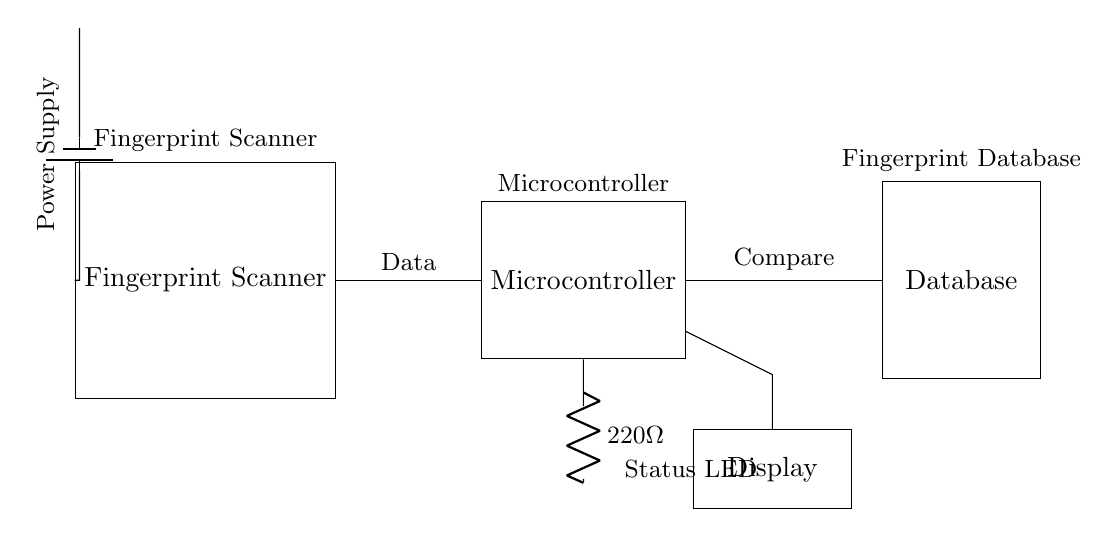What is the main component that collects biometric data? The main component collecting biometric data is the fingerprint scanner, clearly labeled as such in the diagram.
Answer: Fingerprint Scanner What is the purpose of the microcontroller in this circuit? The microcontroller processes the data received from the fingerprint scanner and compares it with the entries in the database.
Answer: Data processing What is connected to the microcontroller for indicating status? A status LED is connected to the microcontroller, which is often used to indicate whether the system is functioning properly or if there is an issue.
Answer: Status LED How is the fingerprint data transmitted to the database? The data from the fingerprint scanner is sent to the microcontroller, which then sends it to the database for comparison.
Answer: Through data connection What resistance value is used in the circuit? A resistor of 220 ohms is used in the circuit, as indicated next to the LED connection.
Answer: Two hundred twenty ohms What is the role of the database in this circuit? The database stores fingerprint data and provides a reference for the microcontroller to compare incoming data against.
Answer: Data comparison What component provides power to the circuit? The power supply, represented as a battery, provides the necessary voltage to operate the entire circuit.
Answer: Power Supply 